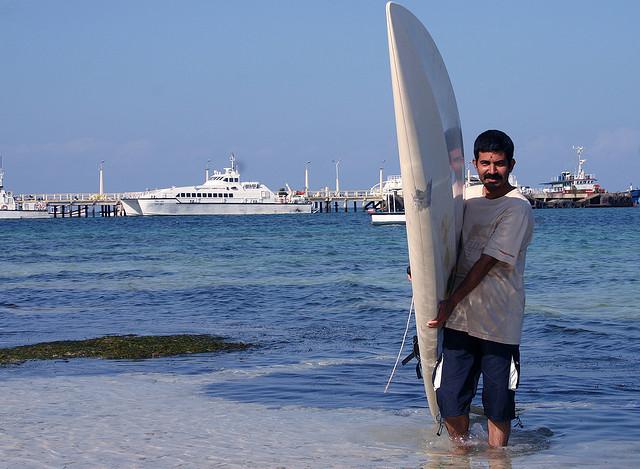Are there any birds in the picture?
Keep it brief. No. Is this man planning to surf?
Quick response, please. Yes. What is the guy wearing?
Quick response, please. Shorts and t shirt. How many surfboards are there?
Answer briefly. 1. What is tied to the surfboard?
Concise answer only. Surfer. What is this man holding?
Answer briefly. Surfboard. Is the surfboard in the sand?
Concise answer only. No. How many surfboards are pictured?
Short answer required. 1. How many surfboard?
Write a very short answer. 1. 